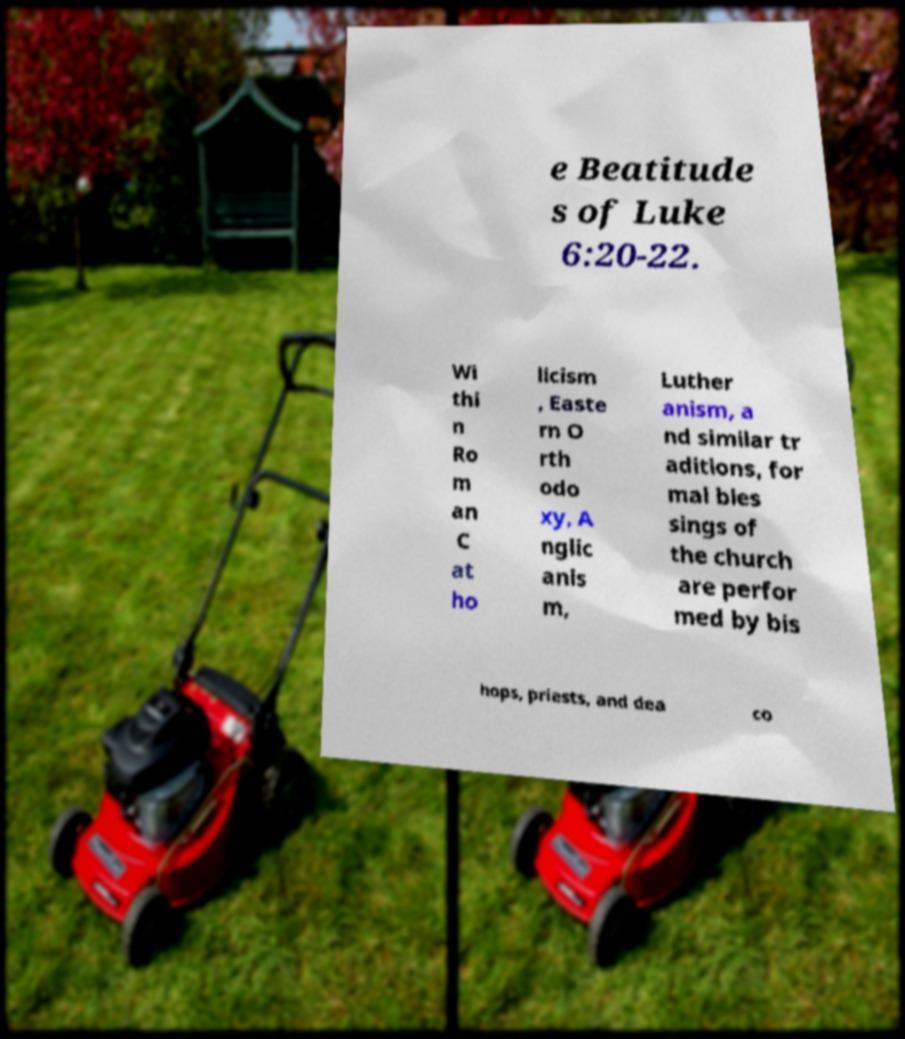Can you accurately transcribe the text from the provided image for me? e Beatitude s of Luke 6:20-22. Wi thi n Ro m an C at ho licism , Easte rn O rth odo xy, A nglic anis m, Luther anism, a nd similar tr aditions, for mal bles sings of the church are perfor med by bis hops, priests, and dea co 